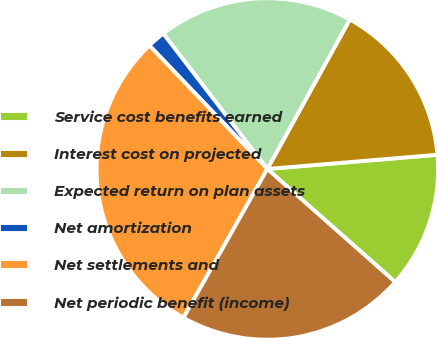<chart> <loc_0><loc_0><loc_500><loc_500><pie_chart><fcel>Service cost benefits earned<fcel>Interest cost on projected<fcel>Expected return on plan assets<fcel>Net amortization<fcel>Net settlements and<fcel>Net periodic benefit (income)<nl><fcel>12.85%<fcel>15.65%<fcel>18.45%<fcel>1.71%<fcel>29.7%<fcel>21.65%<nl></chart> 